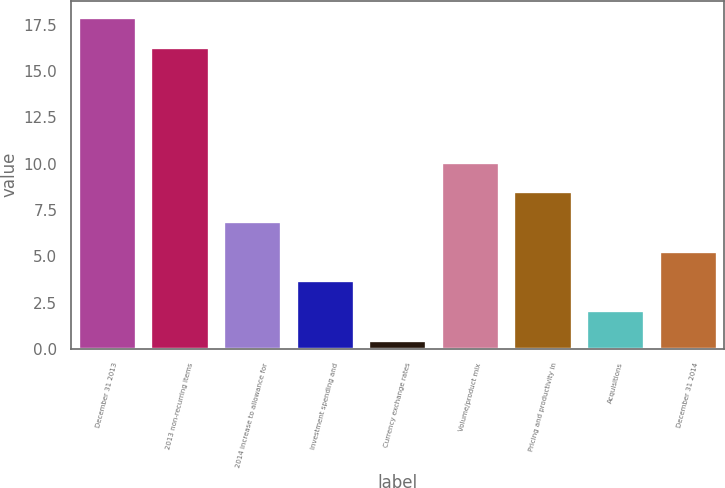Convert chart. <chart><loc_0><loc_0><loc_500><loc_500><bar_chart><fcel>December 31 2013<fcel>2013 non-recurring items<fcel>2014 increase to allowance for<fcel>Investment spending and<fcel>Currency exchange rates<fcel>Volume/product mix<fcel>Pricing and productivity in<fcel>Acquisitions<fcel>December 31 2014<nl><fcel>17.9<fcel>16.3<fcel>6.9<fcel>3.7<fcel>0.5<fcel>10.1<fcel>8.5<fcel>2.1<fcel>5.3<nl></chart> 